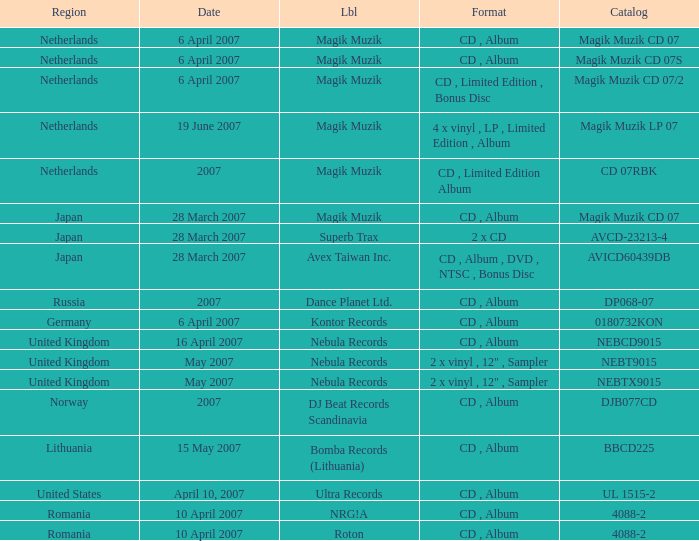Could you parse the entire table? {'header': ['Region', 'Date', 'Lbl', 'Format', 'Catalog'], 'rows': [['Netherlands', '6 April 2007', 'Magik Muzik', 'CD , Album', 'Magik Muzik CD 07'], ['Netherlands', '6 April 2007', 'Magik Muzik', 'CD , Album', 'Magik Muzik CD 07S'], ['Netherlands', '6 April 2007', 'Magik Muzik', 'CD , Limited Edition , Bonus Disc', 'Magik Muzik CD 07/2'], ['Netherlands', '19 June 2007', 'Magik Muzik', '4 x vinyl , LP , Limited Edition , Album', 'Magik Muzik LP 07'], ['Netherlands', '2007', 'Magik Muzik', 'CD , Limited Edition Album', 'CD 07RBK'], ['Japan', '28 March 2007', 'Magik Muzik', 'CD , Album', 'Magik Muzik CD 07'], ['Japan', '28 March 2007', 'Superb Trax', '2 x CD', 'AVCD-23213-4'], ['Japan', '28 March 2007', 'Avex Taiwan Inc.', 'CD , Album , DVD , NTSC , Bonus Disc', 'AVICD60439DB'], ['Russia', '2007', 'Dance Planet Ltd.', 'CD , Album', 'DP068-07'], ['Germany', '6 April 2007', 'Kontor Records', 'CD , Album', '0180732KON'], ['United Kingdom', '16 April 2007', 'Nebula Records', 'CD , Album', 'NEBCD9015'], ['United Kingdom', 'May 2007', 'Nebula Records', '2 x vinyl , 12" , Sampler', 'NEBT9015'], ['United Kingdom', 'May 2007', 'Nebula Records', '2 x vinyl , 12" , Sampler', 'NEBTX9015'], ['Norway', '2007', 'DJ Beat Records Scandinavia', 'CD , Album', 'DJB077CD'], ['Lithuania', '15 May 2007', 'Bomba Records (Lithuania)', 'CD , Album', 'BBCD225'], ['United States', 'April 10, 2007', 'Ultra Records', 'CD , Album', 'UL 1515-2'], ['Romania', '10 April 2007', 'NRG!A', 'CD , Album', '4088-2'], ['Romania', '10 April 2007', 'Roton', 'CD , Album', '4088-2']]} Which label released the catalog Magik Muzik CD 07 on 28 March 2007? Magik Muzik. 